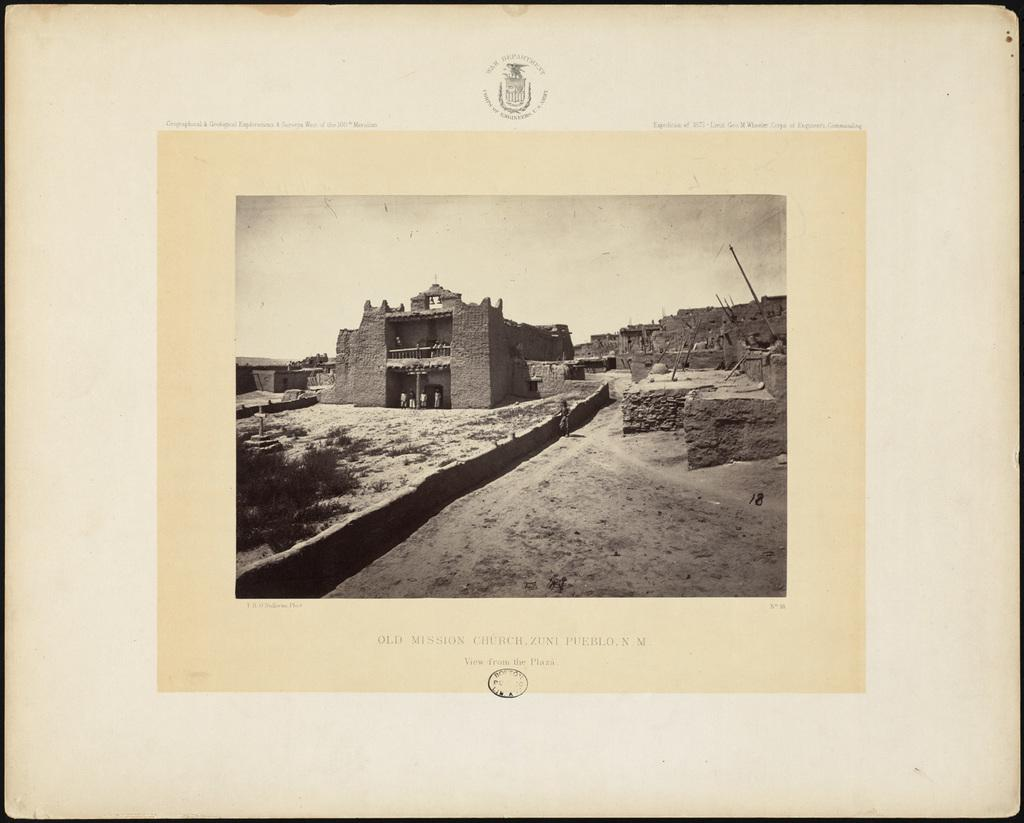<image>
Relay a brief, clear account of the picture shown. Picture of a building and the words "Old Mission Church" under it. 